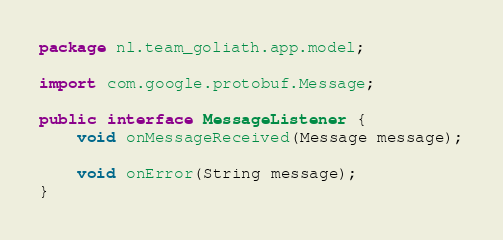<code> <loc_0><loc_0><loc_500><loc_500><_Java_>package nl.team_goliath.app.model;

import com.google.protobuf.Message;

public interface MessageListener {
    void onMessageReceived(Message message);

    void onError(String message);
}</code> 